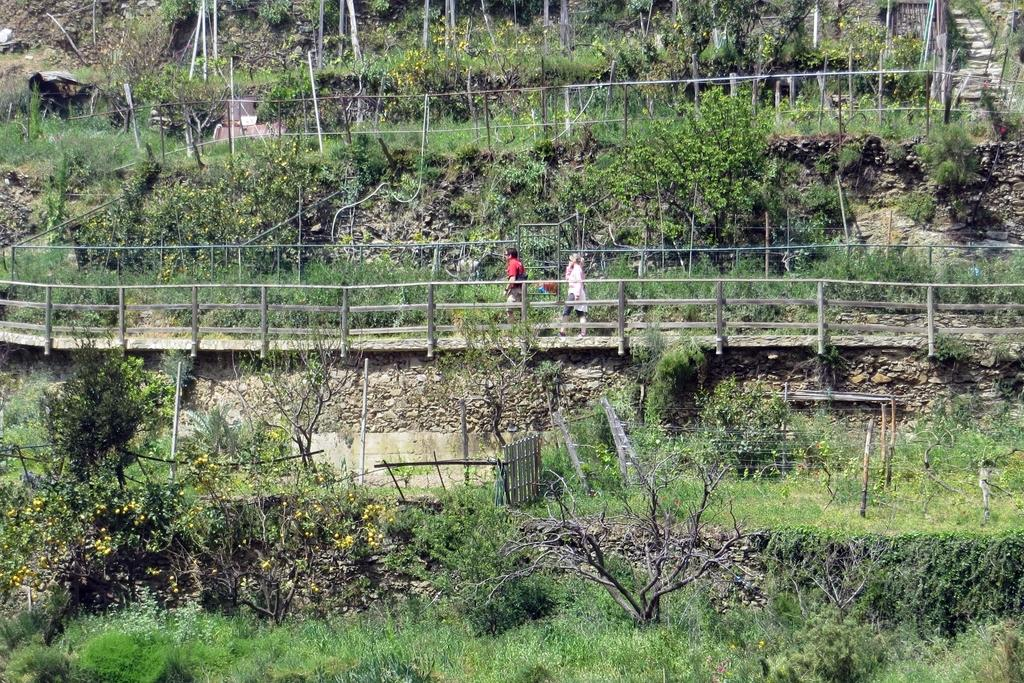How many people are walking in the image? There are two members walking in the image. What surface are they walking on? They are walking on a path. What can be seen near the path in the image? There is a wooden railing in the image. What type of natural elements are present in the image? There are plants and trees in the image. What type of locket can be seen hanging from the tree in the image? There is no locket present in the image; it only features two people walking, a path, a wooden railing, plants, and trees. 